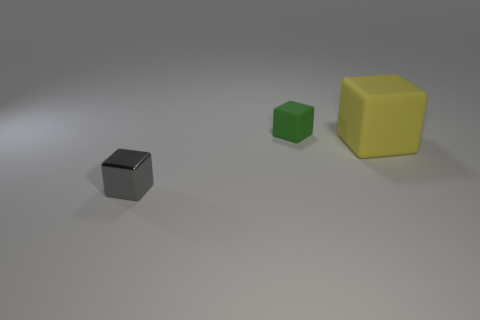Is there any other thing that has the same size as the yellow rubber cube?
Your answer should be compact. No. Are there any other things that have the same material as the small gray block?
Keep it short and to the point. No. What number of other objects are there of the same size as the green thing?
Your answer should be very brief. 1. Is there a green object of the same size as the gray cube?
Give a very brief answer. Yes. Do the thing in front of the large yellow cube and the small matte cube have the same color?
Give a very brief answer. No. How many objects are tiny purple spheres or big things?
Keep it short and to the point. 1. There is a rubber object that is to the left of the yellow rubber thing; is its size the same as the shiny block?
Provide a short and direct response. Yes. There is a block that is in front of the tiny green rubber cube and to the right of the gray block; what is its size?
Offer a very short reply. Large. How many other objects are the same shape as the tiny rubber object?
Your response must be concise. 2. What number of other things are there of the same material as the tiny gray block
Keep it short and to the point. 0. 